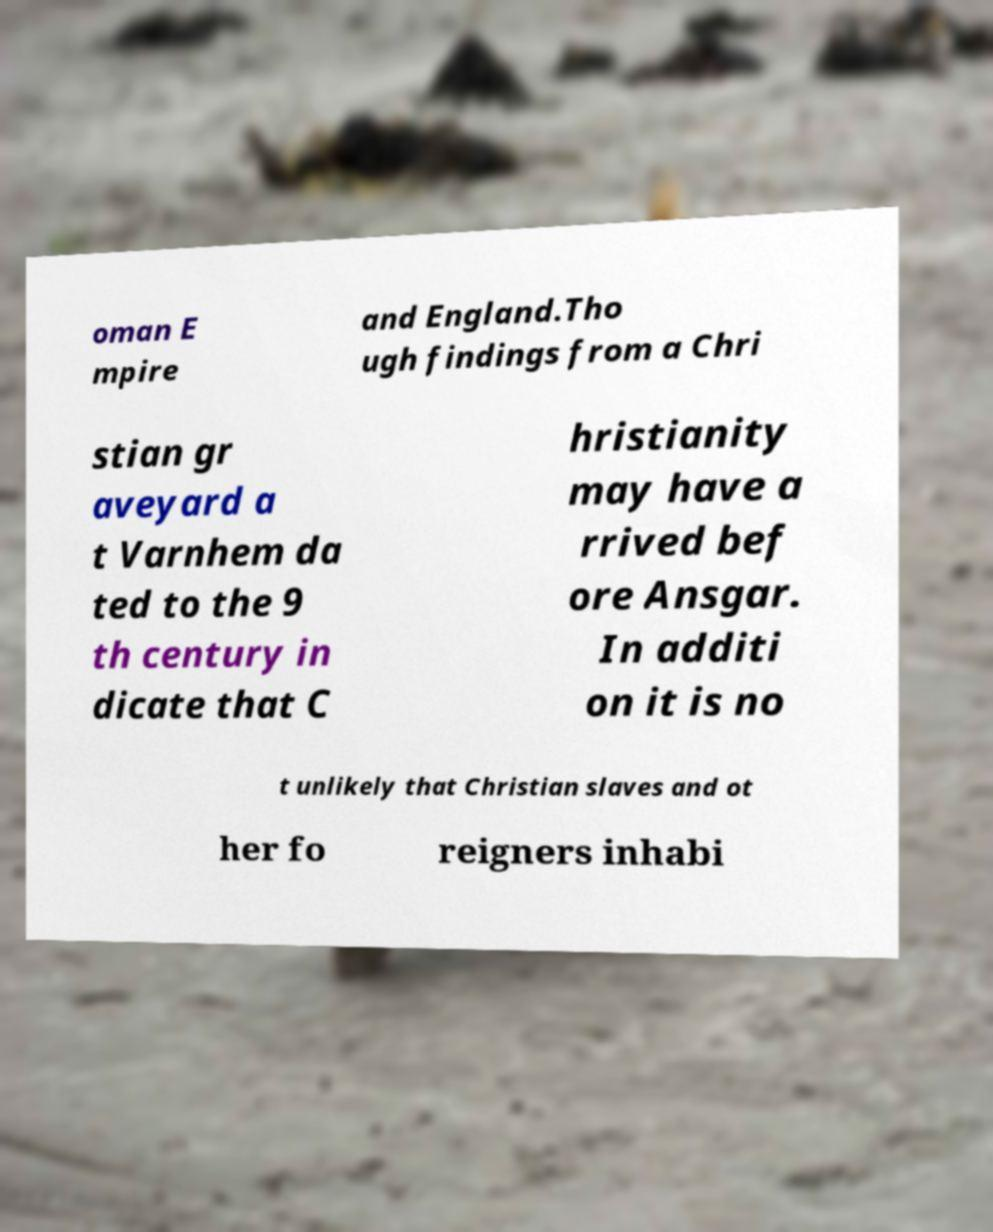Please identify and transcribe the text found in this image. oman E mpire and England.Tho ugh findings from a Chri stian gr aveyard a t Varnhem da ted to the 9 th century in dicate that C hristianity may have a rrived bef ore Ansgar. In additi on it is no t unlikely that Christian slaves and ot her fo reigners inhabi 